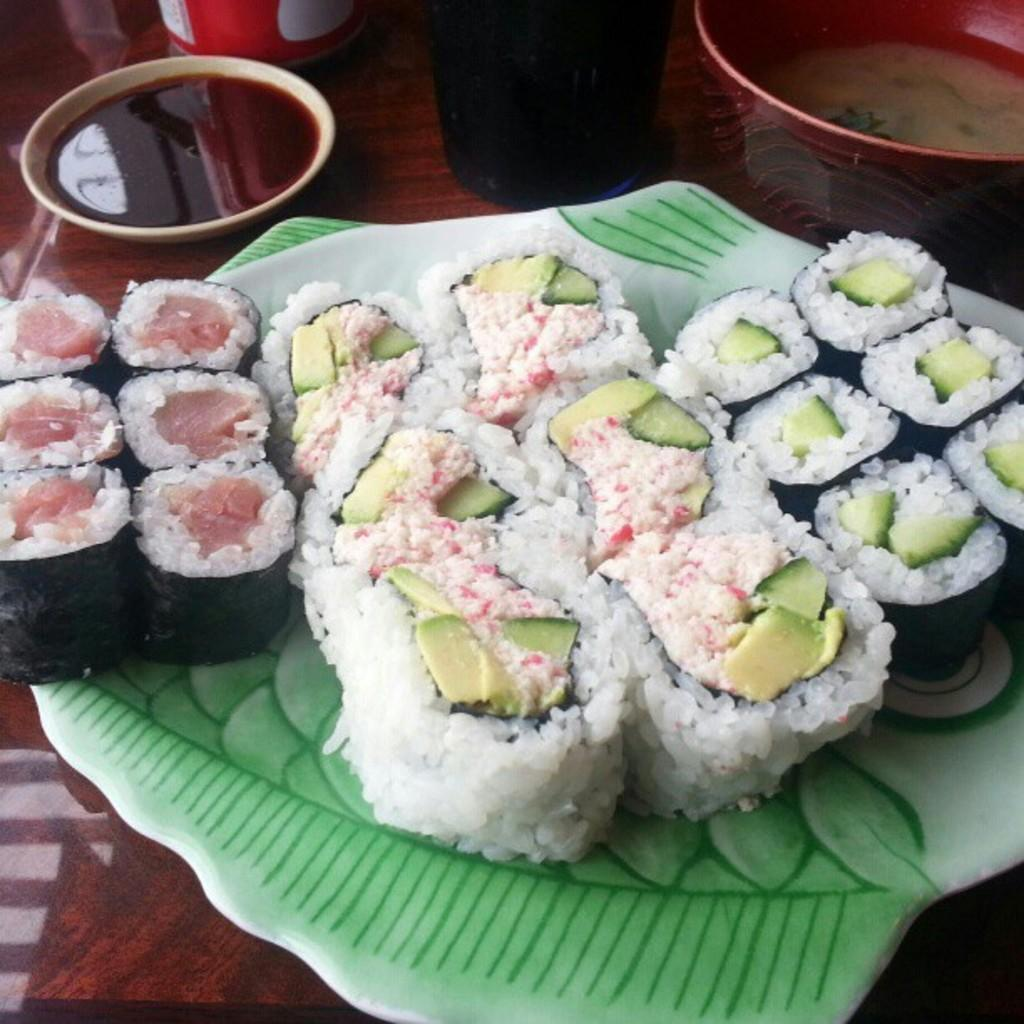What is the main piece of furniture in the image? There is a table in the image. What is placed on the table? There is a tray on the table. What is on the tray? The tray contains sweets. What else can be seen on the table besides the tray? There is a bowl with soup in it. Are there any other bowls on the table? Yes, there is another bowl beside the bowl with soup. What type of weather can be seen in the image? There is no weather depicted in the image, as it is an indoor scene with a table, tray, and bowls. 